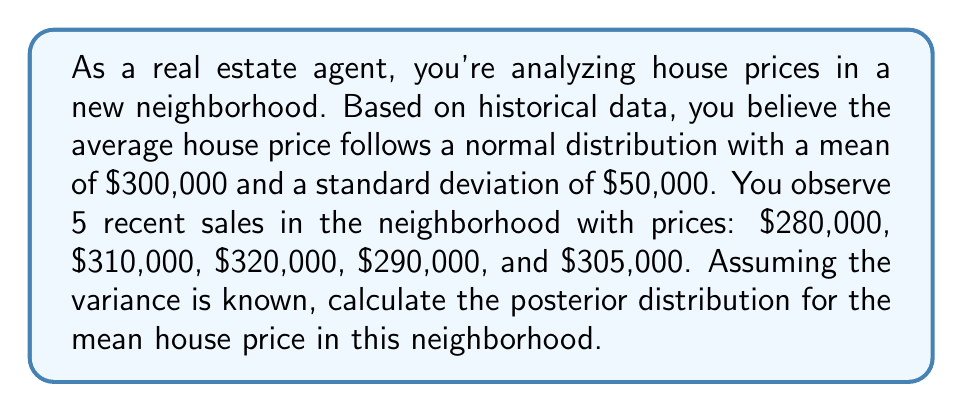Help me with this question. To solve this problem, we'll use Bayesian inference with a known variance. Let's break it down step-by-step:

1) Prior distribution:
   $\mu \sim N(300000, 50000^2)$

2) Likelihood:
   $X_i | \mu \sim N(\mu, \sigma^2)$, where $\sigma$ is unknown but assumed constant

3) Observed data:
   $n = 5$
   $\bar{x} = \frac{280000 + 310000 + 320000 + 290000 + 305000}{5} = 301000$

4) For conjugate normal priors with known variance, the posterior distribution is also normal with parameters:

   $$\mu_{post} = \frac{\frac{\mu_0}{\sigma_0^2} + \frac{n\bar{x}}{\sigma^2}}{\frac{1}{\sigma_0^2} + \frac{n}{\sigma^2}}$$

   $$\sigma_{post}^2 = \frac{1}{\frac{1}{\sigma_0^2} + \frac{n}{\sigma^2}}$$

   Where $\mu_0$ and $\sigma_0^2$ are the prior mean and variance, and $\sigma^2$ is the known variance of the data.

5) We don't know $\sigma^2$, but we can estimate it from the sample:
   $s^2 = \frac{1}{n-1}\sum_{i=1}^n (x_i - \bar{x})^2 = 225000000$

6) Now we can calculate the posterior parameters:

   $$\mu_{post} = \frac{\frac{300000}{50000^2} + \frac{5 \cdot 301000}{225000000}}{\frac{1}{50000^2} + \frac{5}{225000000}} \approx 300778.44$$

   $$\sigma_{post}^2 = \frac{1}{\frac{1}{50000^2} + \frac{5}{225000000}} \approx 1.91 \cdot 10^9$$

Therefore, the posterior distribution is:

$\mu_{post} \sim N(300778.44, \sqrt{1.91 \cdot 10^9})$
Answer: The posterior distribution for the mean house price is a normal distribution with mean $300,778.44 and standard deviation $43,705.89. 